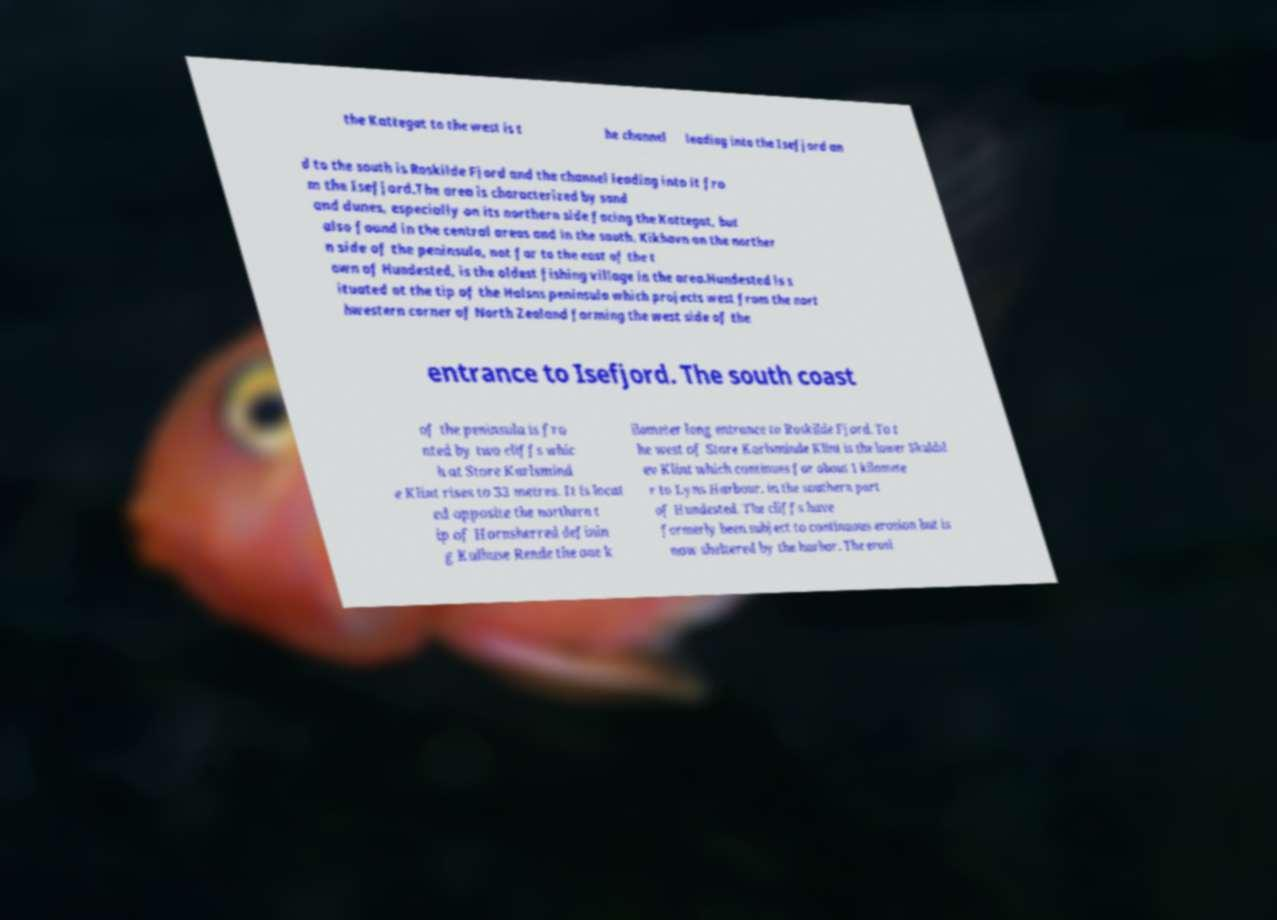Can you read and provide the text displayed in the image?This photo seems to have some interesting text. Can you extract and type it out for me? the Kattegat to the west is t he channel leading into the Isefjord an d to the south is Roskilde Fjord and the channel leading into it fro m the Isefjord.The area is characterized by sand and dunes, especially on its northern side facing the Kattegat, but also found in the central areas and in the south. Kikhavn on the norther n side of the peninsula, not far to the east of the t own of Hundested, is the oldest fishing village in the area.Hundested is s ituated at the tip of the Halsns peninsula which projects west from the nort hwestern corner of North Zealand forming the west side of the entrance to Isefjord. The south coast of the peninsula is fro nted by two cliffs whic h at Store Karlsmind e Klint rises to 33 metres. It is locat ed opposite the northern t ip of Hornsherred definin g Kulhuse Rende the one k ilometer long entrance to Roskilde Fjord. To t he west of Store Karlsminde Klint is the lower Skuldsl ev Klint which continues for about 1 kilomete r to Lyns Harbour. in the southern part of Hundested. The cliffs have formerly been subject to continuous erosion but is now sheltered by the harbor. The erosi 